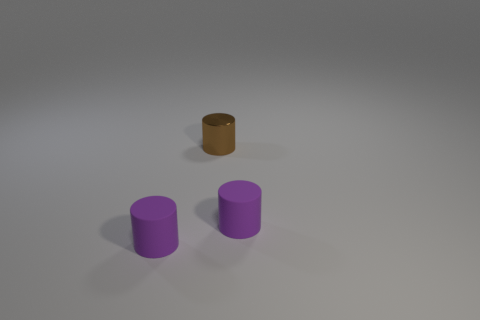Subtract all tiny purple matte cylinders. How many cylinders are left? 1 Subtract all gray blocks. How many purple cylinders are left? 2 Add 3 tiny cylinders. How many objects exist? 6 Add 2 brown objects. How many brown objects exist? 3 Subtract 0 green spheres. How many objects are left? 3 Subtract all tiny metal things. Subtract all rubber things. How many objects are left? 0 Add 3 tiny brown objects. How many tiny brown objects are left? 4 